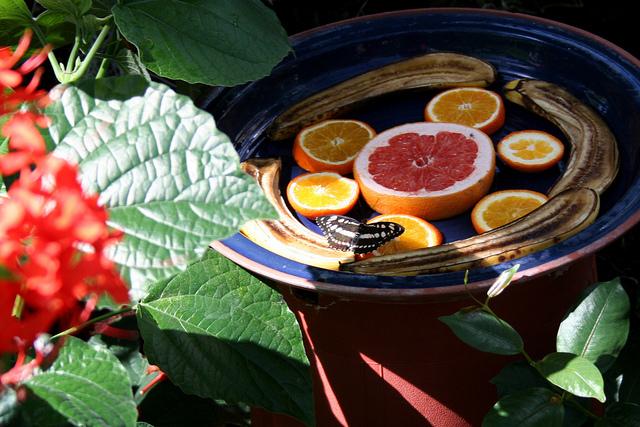What creature is perched at the edge of the plate?
Concise answer only. Butterfly. How many different kinds of fruit are in the bowl?
Write a very short answer. 2. Can you eat the fruits in the bowl?
Be succinct. Yes. 